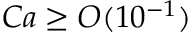<formula> <loc_0><loc_0><loc_500><loc_500>C a \geq O ( 1 0 ^ { - 1 } )</formula> 